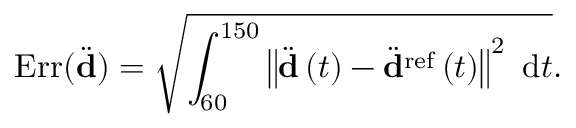<formula> <loc_0><loc_0><loc_500><loc_500>E r r ( \ddot { d } ) = \sqrt { \int _ { 6 0 } ^ { 1 5 0 } { \left \| \ddot { d } \left ( t \right ) - \ddot { d } ^ { r e f } \left ( t \right ) \right \| ^ { 2 } \ d t } } .</formula> 